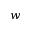Convert formula to latex. <formula><loc_0><loc_0><loc_500><loc_500>w</formula> 